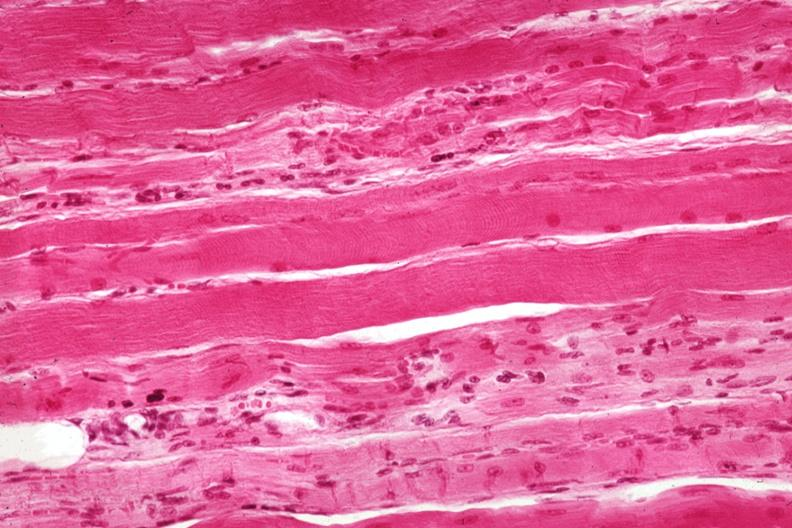what does this image show?
Answer the question using a single word or phrase. Good depiction focal fiber atrophy 